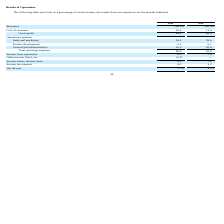From Travelzoo's financial document, What is the gross profit for 2019 and 2018 respectively as a percentage of total revenues? The document shows two values: 89.4 and 89.0 (percentage). From the document: "Gross profit 89.4 89.0 Gross profit 89.4 89.0..." Also, What is the income from operations for 2019 and 2018 respectively as a percentage of total revenues? The document shows two values: 8.5 and 7.4 (percentage). From the document: "Income from operations 8.5 7.4 Income from operations 8.5 7.4..." Also, What is the cost of revenues for 2019 and 2018 respectively as a percentage of total revenues? The document shows two values: 10.6 and 11.0 (percentage). From the document: "Cost of revenues 10.6 11.0 Cost of revenues 10.6 11.0..." Also, can you calculate: What is the average cost of revenue for 2018 and 2019 as a percentage of total revenues? To answer this question, I need to perform calculations using the financial data. The calculation is: (10.6+11.0)/2, which equals 10.8 (percentage). This is based on the information: "Cost of revenues 10.6 11.0 Cost of revenues 10.6 11.0..." The key data points involved are: 10.6, 11.0. Also, can you calculate: What is the change in sales and marketing expenses between 2018 and 2019 as a percentage of total revenues? Based on the calculation: 54.2-52.6, the result is 1.6 (percentage). This is based on the information: "Sales and marketing 54.2 52.6 Sales and marketing 54.2 52.6..." The key data points involved are: 52.6, 54.2. Also, can you calculate: What is the average net income for 2018 and 2019 as a percentage of total revenues? To answer this question, I need to perform calculations using the financial data. The calculation is: (3.7+4.2)/2, which equals 3.95 (percentage). This is based on the information: "Net income 3.7% 4.2% Net income 3.7% 4.2%..." The key data points involved are: 3.7, 4.2. 